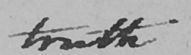Transcribe the text shown in this historical manuscript line. truth 